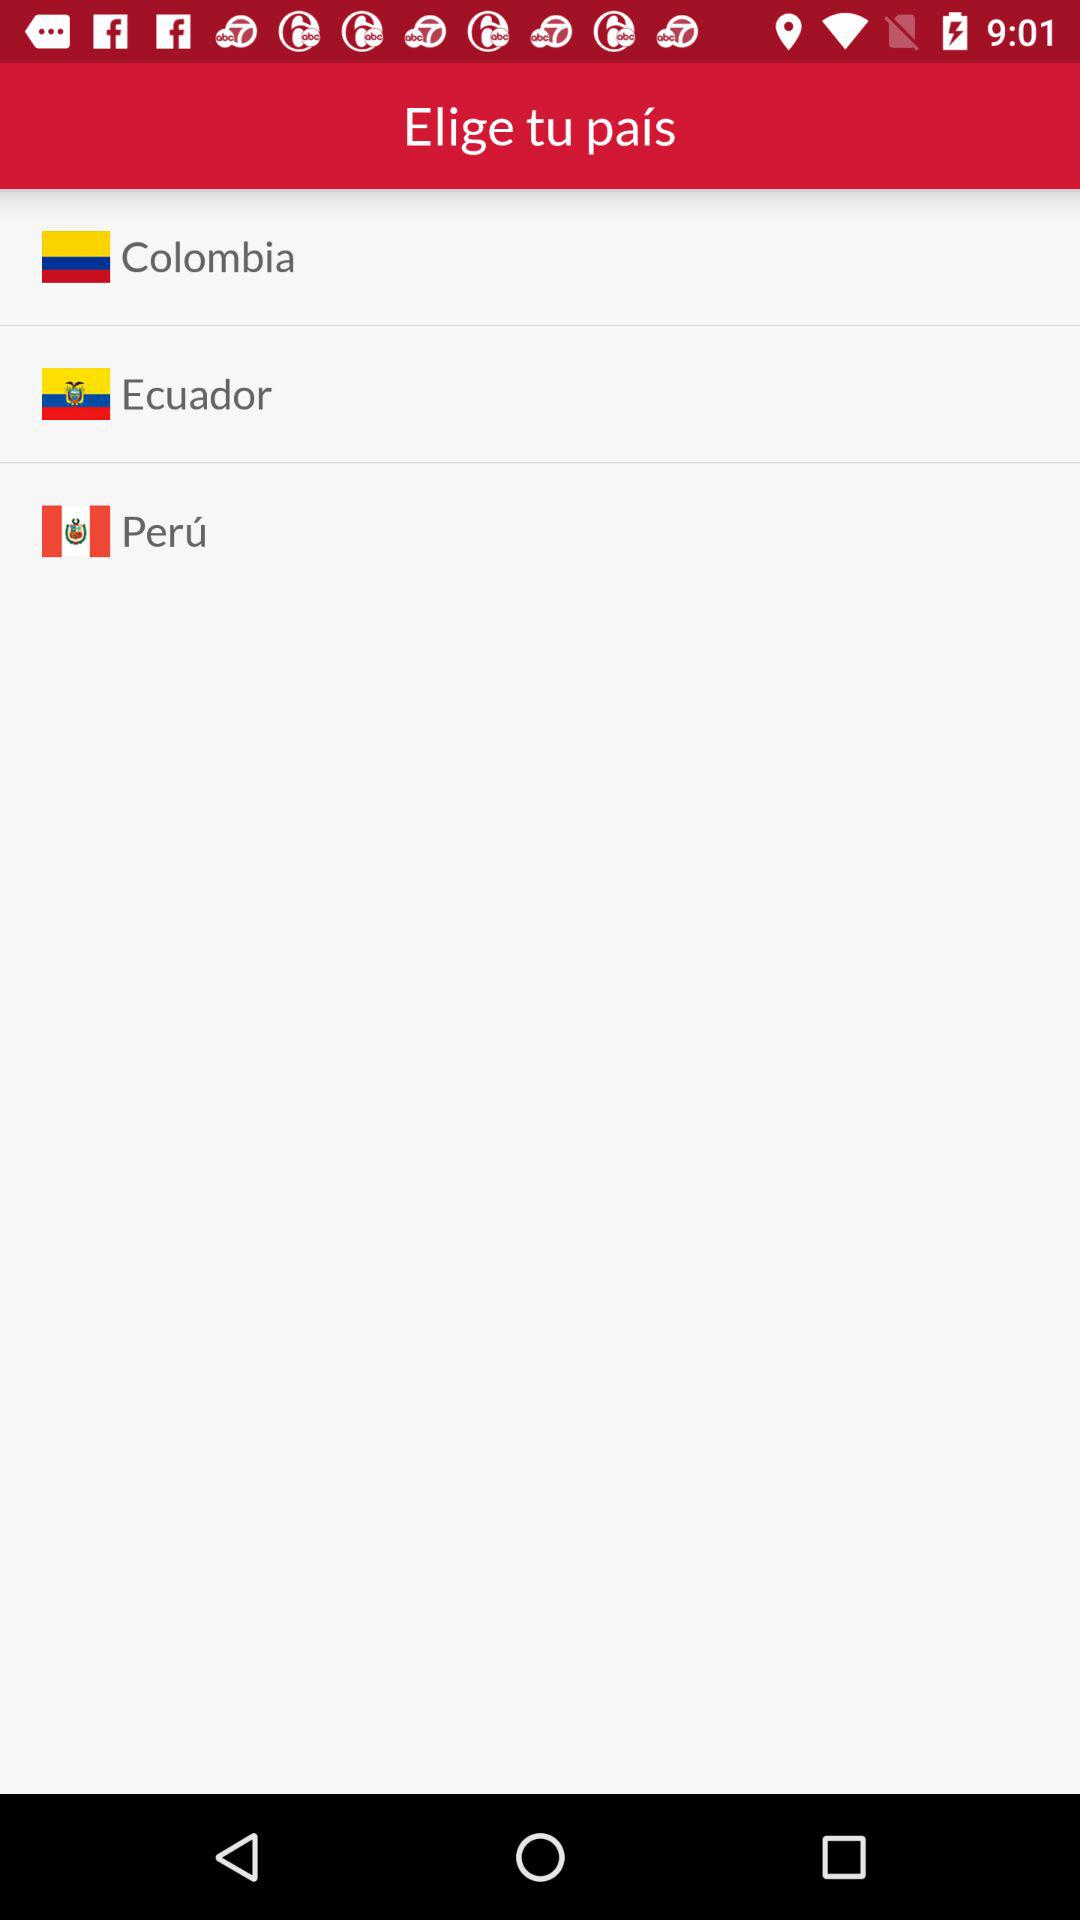How many countries are available to select?
Answer the question using a single word or phrase. 3 